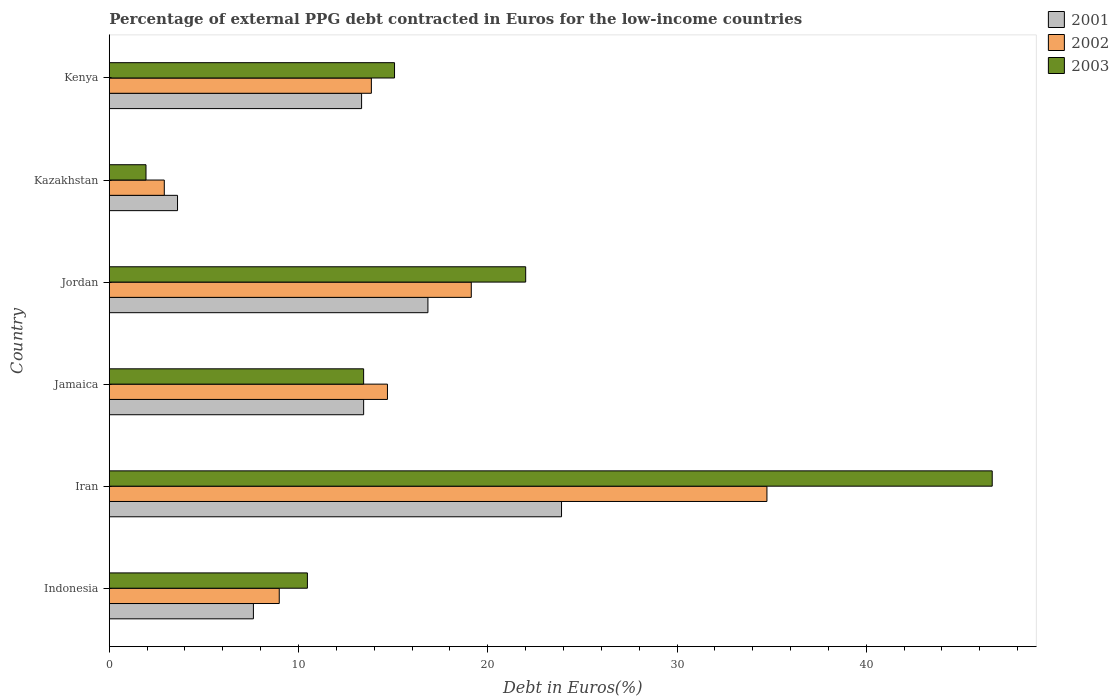How many groups of bars are there?
Your response must be concise. 6. What is the label of the 2nd group of bars from the top?
Offer a terse response. Kazakhstan. In how many cases, is the number of bars for a given country not equal to the number of legend labels?
Provide a short and direct response. 0. What is the percentage of external PPG debt contracted in Euros in 2002 in Jordan?
Give a very brief answer. 19.13. Across all countries, what is the maximum percentage of external PPG debt contracted in Euros in 2001?
Offer a terse response. 23.9. Across all countries, what is the minimum percentage of external PPG debt contracted in Euros in 2001?
Give a very brief answer. 3.61. In which country was the percentage of external PPG debt contracted in Euros in 2002 maximum?
Provide a short and direct response. Iran. In which country was the percentage of external PPG debt contracted in Euros in 2002 minimum?
Your answer should be very brief. Kazakhstan. What is the total percentage of external PPG debt contracted in Euros in 2001 in the graph?
Provide a succinct answer. 78.73. What is the difference between the percentage of external PPG debt contracted in Euros in 2003 in Jamaica and that in Kazakhstan?
Offer a very short reply. 11.5. What is the difference between the percentage of external PPG debt contracted in Euros in 2002 in Jamaica and the percentage of external PPG debt contracted in Euros in 2003 in Iran?
Make the answer very short. -31.96. What is the average percentage of external PPG debt contracted in Euros in 2001 per country?
Your response must be concise. 13.12. What is the difference between the percentage of external PPG debt contracted in Euros in 2002 and percentage of external PPG debt contracted in Euros in 2003 in Iran?
Keep it short and to the point. -11.9. What is the ratio of the percentage of external PPG debt contracted in Euros in 2002 in Jordan to that in Kenya?
Your answer should be very brief. 1.38. Is the percentage of external PPG debt contracted in Euros in 2001 in Kazakhstan less than that in Kenya?
Ensure brevity in your answer.  Yes. Is the difference between the percentage of external PPG debt contracted in Euros in 2002 in Iran and Kenya greater than the difference between the percentage of external PPG debt contracted in Euros in 2003 in Iran and Kenya?
Keep it short and to the point. No. What is the difference between the highest and the second highest percentage of external PPG debt contracted in Euros in 2002?
Your answer should be compact. 15.62. What is the difference between the highest and the lowest percentage of external PPG debt contracted in Euros in 2003?
Your response must be concise. 44.72. What does the 1st bar from the top in Jamaica represents?
Offer a very short reply. 2003. Is it the case that in every country, the sum of the percentage of external PPG debt contracted in Euros in 2001 and percentage of external PPG debt contracted in Euros in 2002 is greater than the percentage of external PPG debt contracted in Euros in 2003?
Your response must be concise. Yes. How many bars are there?
Your answer should be very brief. 18. Are all the bars in the graph horizontal?
Offer a very short reply. Yes. How many countries are there in the graph?
Offer a terse response. 6. Are the values on the major ticks of X-axis written in scientific E-notation?
Offer a very short reply. No. What is the title of the graph?
Make the answer very short. Percentage of external PPG debt contracted in Euros for the low-income countries. What is the label or title of the X-axis?
Your answer should be compact. Debt in Euros(%). What is the Debt in Euros(%) of 2001 in Indonesia?
Provide a short and direct response. 7.62. What is the Debt in Euros(%) in 2002 in Indonesia?
Your answer should be very brief. 8.98. What is the Debt in Euros(%) in 2003 in Indonesia?
Your answer should be compact. 10.47. What is the Debt in Euros(%) in 2001 in Iran?
Your answer should be very brief. 23.9. What is the Debt in Euros(%) of 2002 in Iran?
Provide a short and direct response. 34.75. What is the Debt in Euros(%) of 2003 in Iran?
Offer a terse response. 46.66. What is the Debt in Euros(%) in 2001 in Jamaica?
Provide a succinct answer. 13.44. What is the Debt in Euros(%) of 2002 in Jamaica?
Ensure brevity in your answer.  14.7. What is the Debt in Euros(%) of 2003 in Jamaica?
Offer a terse response. 13.44. What is the Debt in Euros(%) in 2001 in Jordan?
Give a very brief answer. 16.84. What is the Debt in Euros(%) of 2002 in Jordan?
Your response must be concise. 19.13. What is the Debt in Euros(%) in 2003 in Jordan?
Give a very brief answer. 22. What is the Debt in Euros(%) of 2001 in Kazakhstan?
Your answer should be very brief. 3.61. What is the Debt in Euros(%) in 2002 in Kazakhstan?
Offer a very short reply. 2.91. What is the Debt in Euros(%) in 2003 in Kazakhstan?
Your response must be concise. 1.94. What is the Debt in Euros(%) of 2001 in Kenya?
Provide a succinct answer. 13.33. What is the Debt in Euros(%) of 2002 in Kenya?
Keep it short and to the point. 13.85. What is the Debt in Euros(%) in 2003 in Kenya?
Your answer should be very brief. 15.07. Across all countries, what is the maximum Debt in Euros(%) in 2001?
Offer a very short reply. 23.9. Across all countries, what is the maximum Debt in Euros(%) in 2002?
Ensure brevity in your answer.  34.75. Across all countries, what is the maximum Debt in Euros(%) of 2003?
Offer a very short reply. 46.66. Across all countries, what is the minimum Debt in Euros(%) in 2001?
Offer a very short reply. 3.61. Across all countries, what is the minimum Debt in Euros(%) in 2002?
Offer a very short reply. 2.91. Across all countries, what is the minimum Debt in Euros(%) of 2003?
Provide a succinct answer. 1.94. What is the total Debt in Euros(%) in 2001 in the graph?
Offer a very short reply. 78.73. What is the total Debt in Euros(%) in 2002 in the graph?
Make the answer very short. 94.32. What is the total Debt in Euros(%) in 2003 in the graph?
Offer a very short reply. 109.58. What is the difference between the Debt in Euros(%) in 2001 in Indonesia and that in Iran?
Your answer should be compact. -16.28. What is the difference between the Debt in Euros(%) of 2002 in Indonesia and that in Iran?
Offer a terse response. -25.77. What is the difference between the Debt in Euros(%) in 2003 in Indonesia and that in Iran?
Keep it short and to the point. -36.19. What is the difference between the Debt in Euros(%) in 2001 in Indonesia and that in Jamaica?
Your answer should be compact. -5.83. What is the difference between the Debt in Euros(%) in 2002 in Indonesia and that in Jamaica?
Make the answer very short. -5.72. What is the difference between the Debt in Euros(%) of 2003 in Indonesia and that in Jamaica?
Provide a short and direct response. -2.97. What is the difference between the Debt in Euros(%) of 2001 in Indonesia and that in Jordan?
Provide a short and direct response. -9.22. What is the difference between the Debt in Euros(%) in 2002 in Indonesia and that in Jordan?
Give a very brief answer. -10.15. What is the difference between the Debt in Euros(%) of 2003 in Indonesia and that in Jordan?
Keep it short and to the point. -11.53. What is the difference between the Debt in Euros(%) of 2001 in Indonesia and that in Kazakhstan?
Your answer should be very brief. 4.01. What is the difference between the Debt in Euros(%) in 2002 in Indonesia and that in Kazakhstan?
Provide a short and direct response. 6.07. What is the difference between the Debt in Euros(%) in 2003 in Indonesia and that in Kazakhstan?
Offer a very short reply. 8.53. What is the difference between the Debt in Euros(%) in 2001 in Indonesia and that in Kenya?
Provide a succinct answer. -5.72. What is the difference between the Debt in Euros(%) in 2002 in Indonesia and that in Kenya?
Keep it short and to the point. -4.87. What is the difference between the Debt in Euros(%) in 2003 in Indonesia and that in Kenya?
Keep it short and to the point. -4.6. What is the difference between the Debt in Euros(%) of 2001 in Iran and that in Jamaica?
Offer a terse response. 10.46. What is the difference between the Debt in Euros(%) of 2002 in Iran and that in Jamaica?
Provide a short and direct response. 20.05. What is the difference between the Debt in Euros(%) of 2003 in Iran and that in Jamaica?
Your response must be concise. 33.22. What is the difference between the Debt in Euros(%) in 2001 in Iran and that in Jordan?
Your response must be concise. 7.06. What is the difference between the Debt in Euros(%) in 2002 in Iran and that in Jordan?
Offer a terse response. 15.62. What is the difference between the Debt in Euros(%) of 2003 in Iran and that in Jordan?
Your response must be concise. 24.65. What is the difference between the Debt in Euros(%) in 2001 in Iran and that in Kazakhstan?
Your answer should be very brief. 20.29. What is the difference between the Debt in Euros(%) of 2002 in Iran and that in Kazakhstan?
Your response must be concise. 31.84. What is the difference between the Debt in Euros(%) in 2003 in Iran and that in Kazakhstan?
Give a very brief answer. 44.72. What is the difference between the Debt in Euros(%) of 2001 in Iran and that in Kenya?
Provide a short and direct response. 10.57. What is the difference between the Debt in Euros(%) in 2002 in Iran and that in Kenya?
Your response must be concise. 20.9. What is the difference between the Debt in Euros(%) in 2003 in Iran and that in Kenya?
Your answer should be compact. 31.58. What is the difference between the Debt in Euros(%) of 2001 in Jamaica and that in Jordan?
Keep it short and to the point. -3.4. What is the difference between the Debt in Euros(%) in 2002 in Jamaica and that in Jordan?
Your response must be concise. -4.43. What is the difference between the Debt in Euros(%) of 2003 in Jamaica and that in Jordan?
Make the answer very short. -8.56. What is the difference between the Debt in Euros(%) in 2001 in Jamaica and that in Kazakhstan?
Your response must be concise. 9.83. What is the difference between the Debt in Euros(%) of 2002 in Jamaica and that in Kazakhstan?
Your response must be concise. 11.79. What is the difference between the Debt in Euros(%) in 2003 in Jamaica and that in Kazakhstan?
Your response must be concise. 11.5. What is the difference between the Debt in Euros(%) of 2001 in Jamaica and that in Kenya?
Give a very brief answer. 0.11. What is the difference between the Debt in Euros(%) in 2002 in Jamaica and that in Kenya?
Provide a short and direct response. 0.85. What is the difference between the Debt in Euros(%) in 2003 in Jamaica and that in Kenya?
Offer a very short reply. -1.63. What is the difference between the Debt in Euros(%) of 2001 in Jordan and that in Kazakhstan?
Ensure brevity in your answer.  13.23. What is the difference between the Debt in Euros(%) in 2002 in Jordan and that in Kazakhstan?
Offer a very short reply. 16.22. What is the difference between the Debt in Euros(%) in 2003 in Jordan and that in Kazakhstan?
Offer a terse response. 20.06. What is the difference between the Debt in Euros(%) in 2001 in Jordan and that in Kenya?
Provide a short and direct response. 3.51. What is the difference between the Debt in Euros(%) of 2002 in Jordan and that in Kenya?
Keep it short and to the point. 5.28. What is the difference between the Debt in Euros(%) in 2003 in Jordan and that in Kenya?
Your response must be concise. 6.93. What is the difference between the Debt in Euros(%) of 2001 in Kazakhstan and that in Kenya?
Ensure brevity in your answer.  -9.73. What is the difference between the Debt in Euros(%) of 2002 in Kazakhstan and that in Kenya?
Your answer should be very brief. -10.94. What is the difference between the Debt in Euros(%) of 2003 in Kazakhstan and that in Kenya?
Offer a very short reply. -13.13. What is the difference between the Debt in Euros(%) of 2001 in Indonesia and the Debt in Euros(%) of 2002 in Iran?
Offer a terse response. -27.14. What is the difference between the Debt in Euros(%) of 2001 in Indonesia and the Debt in Euros(%) of 2003 in Iran?
Offer a terse response. -39.04. What is the difference between the Debt in Euros(%) in 2002 in Indonesia and the Debt in Euros(%) in 2003 in Iran?
Keep it short and to the point. -37.67. What is the difference between the Debt in Euros(%) in 2001 in Indonesia and the Debt in Euros(%) in 2002 in Jamaica?
Keep it short and to the point. -7.08. What is the difference between the Debt in Euros(%) of 2001 in Indonesia and the Debt in Euros(%) of 2003 in Jamaica?
Your response must be concise. -5.82. What is the difference between the Debt in Euros(%) of 2002 in Indonesia and the Debt in Euros(%) of 2003 in Jamaica?
Keep it short and to the point. -4.46. What is the difference between the Debt in Euros(%) in 2001 in Indonesia and the Debt in Euros(%) in 2002 in Jordan?
Give a very brief answer. -11.51. What is the difference between the Debt in Euros(%) in 2001 in Indonesia and the Debt in Euros(%) in 2003 in Jordan?
Ensure brevity in your answer.  -14.39. What is the difference between the Debt in Euros(%) of 2002 in Indonesia and the Debt in Euros(%) of 2003 in Jordan?
Offer a terse response. -13.02. What is the difference between the Debt in Euros(%) of 2001 in Indonesia and the Debt in Euros(%) of 2002 in Kazakhstan?
Give a very brief answer. 4.71. What is the difference between the Debt in Euros(%) of 2001 in Indonesia and the Debt in Euros(%) of 2003 in Kazakhstan?
Give a very brief answer. 5.68. What is the difference between the Debt in Euros(%) of 2002 in Indonesia and the Debt in Euros(%) of 2003 in Kazakhstan?
Provide a short and direct response. 7.04. What is the difference between the Debt in Euros(%) of 2001 in Indonesia and the Debt in Euros(%) of 2002 in Kenya?
Give a very brief answer. -6.23. What is the difference between the Debt in Euros(%) of 2001 in Indonesia and the Debt in Euros(%) of 2003 in Kenya?
Give a very brief answer. -7.46. What is the difference between the Debt in Euros(%) in 2002 in Indonesia and the Debt in Euros(%) in 2003 in Kenya?
Ensure brevity in your answer.  -6.09. What is the difference between the Debt in Euros(%) in 2001 in Iran and the Debt in Euros(%) in 2002 in Jamaica?
Your answer should be very brief. 9.2. What is the difference between the Debt in Euros(%) of 2001 in Iran and the Debt in Euros(%) of 2003 in Jamaica?
Offer a very short reply. 10.46. What is the difference between the Debt in Euros(%) in 2002 in Iran and the Debt in Euros(%) in 2003 in Jamaica?
Keep it short and to the point. 21.31. What is the difference between the Debt in Euros(%) of 2001 in Iran and the Debt in Euros(%) of 2002 in Jordan?
Make the answer very short. 4.77. What is the difference between the Debt in Euros(%) in 2001 in Iran and the Debt in Euros(%) in 2003 in Jordan?
Your answer should be compact. 1.89. What is the difference between the Debt in Euros(%) in 2002 in Iran and the Debt in Euros(%) in 2003 in Jordan?
Give a very brief answer. 12.75. What is the difference between the Debt in Euros(%) of 2001 in Iran and the Debt in Euros(%) of 2002 in Kazakhstan?
Provide a succinct answer. 20.99. What is the difference between the Debt in Euros(%) in 2001 in Iran and the Debt in Euros(%) in 2003 in Kazakhstan?
Offer a very short reply. 21.96. What is the difference between the Debt in Euros(%) of 2002 in Iran and the Debt in Euros(%) of 2003 in Kazakhstan?
Your answer should be compact. 32.81. What is the difference between the Debt in Euros(%) of 2001 in Iran and the Debt in Euros(%) of 2002 in Kenya?
Your answer should be compact. 10.05. What is the difference between the Debt in Euros(%) of 2001 in Iran and the Debt in Euros(%) of 2003 in Kenya?
Offer a very short reply. 8.82. What is the difference between the Debt in Euros(%) of 2002 in Iran and the Debt in Euros(%) of 2003 in Kenya?
Your response must be concise. 19.68. What is the difference between the Debt in Euros(%) in 2001 in Jamaica and the Debt in Euros(%) in 2002 in Jordan?
Offer a terse response. -5.69. What is the difference between the Debt in Euros(%) of 2001 in Jamaica and the Debt in Euros(%) of 2003 in Jordan?
Your answer should be compact. -8.56. What is the difference between the Debt in Euros(%) in 2002 in Jamaica and the Debt in Euros(%) in 2003 in Jordan?
Provide a short and direct response. -7.3. What is the difference between the Debt in Euros(%) in 2001 in Jamaica and the Debt in Euros(%) in 2002 in Kazakhstan?
Offer a very short reply. 10.53. What is the difference between the Debt in Euros(%) of 2001 in Jamaica and the Debt in Euros(%) of 2003 in Kazakhstan?
Your answer should be compact. 11.5. What is the difference between the Debt in Euros(%) of 2002 in Jamaica and the Debt in Euros(%) of 2003 in Kazakhstan?
Give a very brief answer. 12.76. What is the difference between the Debt in Euros(%) in 2001 in Jamaica and the Debt in Euros(%) in 2002 in Kenya?
Make the answer very short. -0.41. What is the difference between the Debt in Euros(%) in 2001 in Jamaica and the Debt in Euros(%) in 2003 in Kenya?
Offer a terse response. -1.63. What is the difference between the Debt in Euros(%) in 2002 in Jamaica and the Debt in Euros(%) in 2003 in Kenya?
Your answer should be compact. -0.37. What is the difference between the Debt in Euros(%) in 2001 in Jordan and the Debt in Euros(%) in 2002 in Kazakhstan?
Offer a very short reply. 13.93. What is the difference between the Debt in Euros(%) in 2001 in Jordan and the Debt in Euros(%) in 2003 in Kazakhstan?
Your answer should be compact. 14.9. What is the difference between the Debt in Euros(%) in 2002 in Jordan and the Debt in Euros(%) in 2003 in Kazakhstan?
Your answer should be very brief. 17.19. What is the difference between the Debt in Euros(%) in 2001 in Jordan and the Debt in Euros(%) in 2002 in Kenya?
Your answer should be very brief. 2.99. What is the difference between the Debt in Euros(%) in 2001 in Jordan and the Debt in Euros(%) in 2003 in Kenya?
Offer a very short reply. 1.76. What is the difference between the Debt in Euros(%) in 2002 in Jordan and the Debt in Euros(%) in 2003 in Kenya?
Keep it short and to the point. 4.06. What is the difference between the Debt in Euros(%) of 2001 in Kazakhstan and the Debt in Euros(%) of 2002 in Kenya?
Keep it short and to the point. -10.24. What is the difference between the Debt in Euros(%) in 2001 in Kazakhstan and the Debt in Euros(%) in 2003 in Kenya?
Provide a short and direct response. -11.47. What is the difference between the Debt in Euros(%) of 2002 in Kazakhstan and the Debt in Euros(%) of 2003 in Kenya?
Provide a succinct answer. -12.17. What is the average Debt in Euros(%) of 2001 per country?
Keep it short and to the point. 13.12. What is the average Debt in Euros(%) in 2002 per country?
Provide a short and direct response. 15.72. What is the average Debt in Euros(%) of 2003 per country?
Your answer should be compact. 18.26. What is the difference between the Debt in Euros(%) of 2001 and Debt in Euros(%) of 2002 in Indonesia?
Your answer should be compact. -1.37. What is the difference between the Debt in Euros(%) in 2001 and Debt in Euros(%) in 2003 in Indonesia?
Your answer should be very brief. -2.85. What is the difference between the Debt in Euros(%) of 2002 and Debt in Euros(%) of 2003 in Indonesia?
Ensure brevity in your answer.  -1.49. What is the difference between the Debt in Euros(%) in 2001 and Debt in Euros(%) in 2002 in Iran?
Provide a succinct answer. -10.85. What is the difference between the Debt in Euros(%) of 2001 and Debt in Euros(%) of 2003 in Iran?
Your answer should be compact. -22.76. What is the difference between the Debt in Euros(%) in 2002 and Debt in Euros(%) in 2003 in Iran?
Give a very brief answer. -11.9. What is the difference between the Debt in Euros(%) of 2001 and Debt in Euros(%) of 2002 in Jamaica?
Offer a very short reply. -1.26. What is the difference between the Debt in Euros(%) in 2001 and Debt in Euros(%) in 2003 in Jamaica?
Provide a short and direct response. 0. What is the difference between the Debt in Euros(%) of 2002 and Debt in Euros(%) of 2003 in Jamaica?
Provide a succinct answer. 1.26. What is the difference between the Debt in Euros(%) in 2001 and Debt in Euros(%) in 2002 in Jordan?
Ensure brevity in your answer.  -2.29. What is the difference between the Debt in Euros(%) in 2001 and Debt in Euros(%) in 2003 in Jordan?
Give a very brief answer. -5.17. What is the difference between the Debt in Euros(%) of 2002 and Debt in Euros(%) of 2003 in Jordan?
Give a very brief answer. -2.87. What is the difference between the Debt in Euros(%) in 2001 and Debt in Euros(%) in 2002 in Kazakhstan?
Provide a succinct answer. 0.7. What is the difference between the Debt in Euros(%) in 2001 and Debt in Euros(%) in 2003 in Kazakhstan?
Your response must be concise. 1.67. What is the difference between the Debt in Euros(%) in 2001 and Debt in Euros(%) in 2002 in Kenya?
Keep it short and to the point. -0.52. What is the difference between the Debt in Euros(%) of 2001 and Debt in Euros(%) of 2003 in Kenya?
Offer a terse response. -1.74. What is the difference between the Debt in Euros(%) of 2002 and Debt in Euros(%) of 2003 in Kenya?
Offer a very short reply. -1.22. What is the ratio of the Debt in Euros(%) of 2001 in Indonesia to that in Iran?
Your response must be concise. 0.32. What is the ratio of the Debt in Euros(%) in 2002 in Indonesia to that in Iran?
Your answer should be compact. 0.26. What is the ratio of the Debt in Euros(%) in 2003 in Indonesia to that in Iran?
Offer a terse response. 0.22. What is the ratio of the Debt in Euros(%) of 2001 in Indonesia to that in Jamaica?
Your answer should be compact. 0.57. What is the ratio of the Debt in Euros(%) of 2002 in Indonesia to that in Jamaica?
Your response must be concise. 0.61. What is the ratio of the Debt in Euros(%) in 2003 in Indonesia to that in Jamaica?
Give a very brief answer. 0.78. What is the ratio of the Debt in Euros(%) in 2001 in Indonesia to that in Jordan?
Offer a terse response. 0.45. What is the ratio of the Debt in Euros(%) of 2002 in Indonesia to that in Jordan?
Offer a terse response. 0.47. What is the ratio of the Debt in Euros(%) in 2003 in Indonesia to that in Jordan?
Your answer should be very brief. 0.48. What is the ratio of the Debt in Euros(%) of 2001 in Indonesia to that in Kazakhstan?
Provide a succinct answer. 2.11. What is the ratio of the Debt in Euros(%) in 2002 in Indonesia to that in Kazakhstan?
Offer a terse response. 3.09. What is the ratio of the Debt in Euros(%) in 2003 in Indonesia to that in Kazakhstan?
Ensure brevity in your answer.  5.4. What is the ratio of the Debt in Euros(%) of 2001 in Indonesia to that in Kenya?
Offer a very short reply. 0.57. What is the ratio of the Debt in Euros(%) in 2002 in Indonesia to that in Kenya?
Give a very brief answer. 0.65. What is the ratio of the Debt in Euros(%) of 2003 in Indonesia to that in Kenya?
Provide a short and direct response. 0.69. What is the ratio of the Debt in Euros(%) of 2001 in Iran to that in Jamaica?
Your response must be concise. 1.78. What is the ratio of the Debt in Euros(%) in 2002 in Iran to that in Jamaica?
Your answer should be compact. 2.36. What is the ratio of the Debt in Euros(%) in 2003 in Iran to that in Jamaica?
Provide a short and direct response. 3.47. What is the ratio of the Debt in Euros(%) in 2001 in Iran to that in Jordan?
Your answer should be very brief. 1.42. What is the ratio of the Debt in Euros(%) of 2002 in Iran to that in Jordan?
Your response must be concise. 1.82. What is the ratio of the Debt in Euros(%) of 2003 in Iran to that in Jordan?
Offer a terse response. 2.12. What is the ratio of the Debt in Euros(%) of 2001 in Iran to that in Kazakhstan?
Provide a succinct answer. 6.63. What is the ratio of the Debt in Euros(%) of 2002 in Iran to that in Kazakhstan?
Give a very brief answer. 11.95. What is the ratio of the Debt in Euros(%) of 2003 in Iran to that in Kazakhstan?
Keep it short and to the point. 24.05. What is the ratio of the Debt in Euros(%) of 2001 in Iran to that in Kenya?
Offer a very short reply. 1.79. What is the ratio of the Debt in Euros(%) of 2002 in Iran to that in Kenya?
Your answer should be very brief. 2.51. What is the ratio of the Debt in Euros(%) of 2003 in Iran to that in Kenya?
Your answer should be compact. 3.1. What is the ratio of the Debt in Euros(%) of 2001 in Jamaica to that in Jordan?
Your answer should be very brief. 0.8. What is the ratio of the Debt in Euros(%) in 2002 in Jamaica to that in Jordan?
Give a very brief answer. 0.77. What is the ratio of the Debt in Euros(%) of 2003 in Jamaica to that in Jordan?
Make the answer very short. 0.61. What is the ratio of the Debt in Euros(%) in 2001 in Jamaica to that in Kazakhstan?
Your answer should be compact. 3.73. What is the ratio of the Debt in Euros(%) in 2002 in Jamaica to that in Kazakhstan?
Your answer should be compact. 5.06. What is the ratio of the Debt in Euros(%) of 2003 in Jamaica to that in Kazakhstan?
Your answer should be compact. 6.93. What is the ratio of the Debt in Euros(%) of 2001 in Jamaica to that in Kenya?
Give a very brief answer. 1.01. What is the ratio of the Debt in Euros(%) in 2002 in Jamaica to that in Kenya?
Make the answer very short. 1.06. What is the ratio of the Debt in Euros(%) in 2003 in Jamaica to that in Kenya?
Your response must be concise. 0.89. What is the ratio of the Debt in Euros(%) of 2001 in Jordan to that in Kazakhstan?
Offer a terse response. 4.67. What is the ratio of the Debt in Euros(%) in 2002 in Jordan to that in Kazakhstan?
Ensure brevity in your answer.  6.58. What is the ratio of the Debt in Euros(%) of 2003 in Jordan to that in Kazakhstan?
Your response must be concise. 11.34. What is the ratio of the Debt in Euros(%) in 2001 in Jordan to that in Kenya?
Give a very brief answer. 1.26. What is the ratio of the Debt in Euros(%) of 2002 in Jordan to that in Kenya?
Keep it short and to the point. 1.38. What is the ratio of the Debt in Euros(%) in 2003 in Jordan to that in Kenya?
Your answer should be very brief. 1.46. What is the ratio of the Debt in Euros(%) of 2001 in Kazakhstan to that in Kenya?
Keep it short and to the point. 0.27. What is the ratio of the Debt in Euros(%) in 2002 in Kazakhstan to that in Kenya?
Keep it short and to the point. 0.21. What is the ratio of the Debt in Euros(%) in 2003 in Kazakhstan to that in Kenya?
Your answer should be very brief. 0.13. What is the difference between the highest and the second highest Debt in Euros(%) of 2001?
Your answer should be very brief. 7.06. What is the difference between the highest and the second highest Debt in Euros(%) in 2002?
Provide a short and direct response. 15.62. What is the difference between the highest and the second highest Debt in Euros(%) of 2003?
Provide a short and direct response. 24.65. What is the difference between the highest and the lowest Debt in Euros(%) of 2001?
Your answer should be compact. 20.29. What is the difference between the highest and the lowest Debt in Euros(%) in 2002?
Offer a terse response. 31.84. What is the difference between the highest and the lowest Debt in Euros(%) of 2003?
Provide a short and direct response. 44.72. 